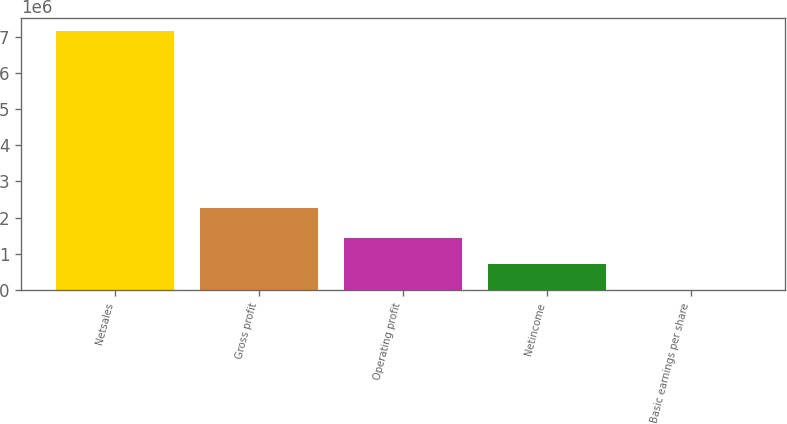Convert chart to OTSL. <chart><loc_0><loc_0><loc_500><loc_500><bar_chart><fcel>Netsales<fcel>Gross profit<fcel>Operating profit<fcel>Netincome<fcel>Basic earnings per share<nl><fcel>7.15764e+06<fcel>2.27276e+06<fcel>1.43153e+06<fcel>715766<fcel>2.11<nl></chart> 